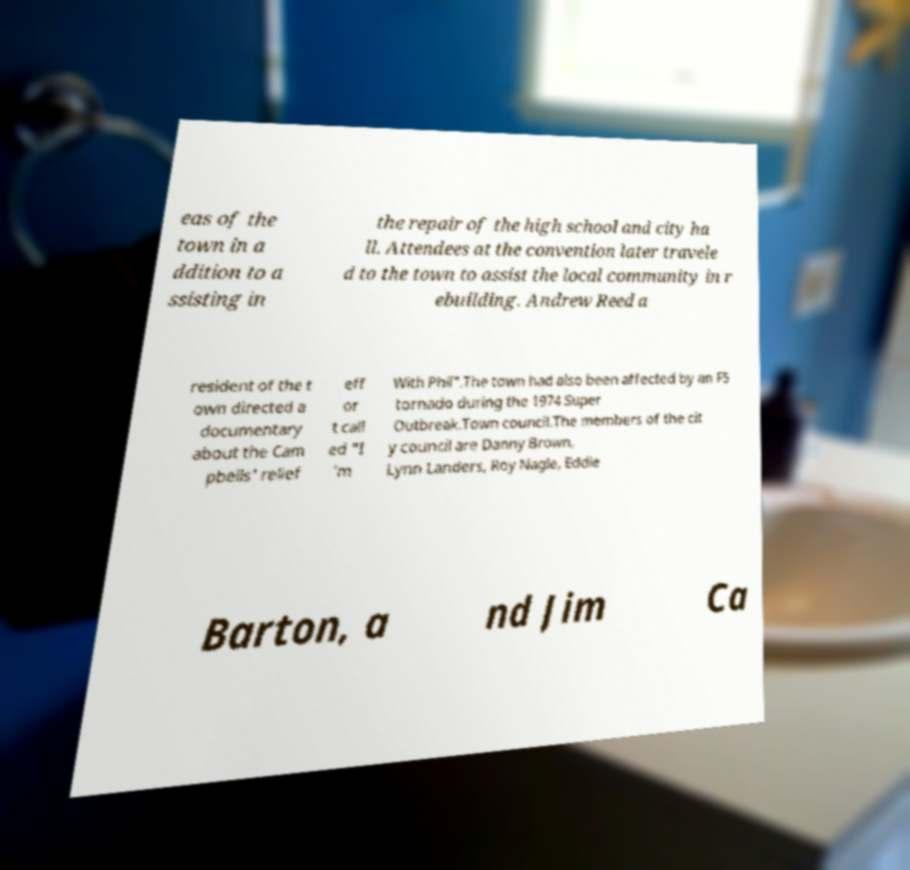Can you read and provide the text displayed in the image?This photo seems to have some interesting text. Can you extract and type it out for me? eas of the town in a ddition to a ssisting in the repair of the high school and city ha ll. Attendees at the convention later travele d to the town to assist the local community in r ebuilding. Andrew Reed a resident of the t own directed a documentary about the Cam pbells' relief eff or t call ed "I 'm With Phil".The town had also been affected by an F5 tornado during the 1974 Super Outbreak.Town council.The members of the cit y council are Danny Brown, Lynn Landers, Roy Nagle, Eddie Barton, a nd Jim Ca 